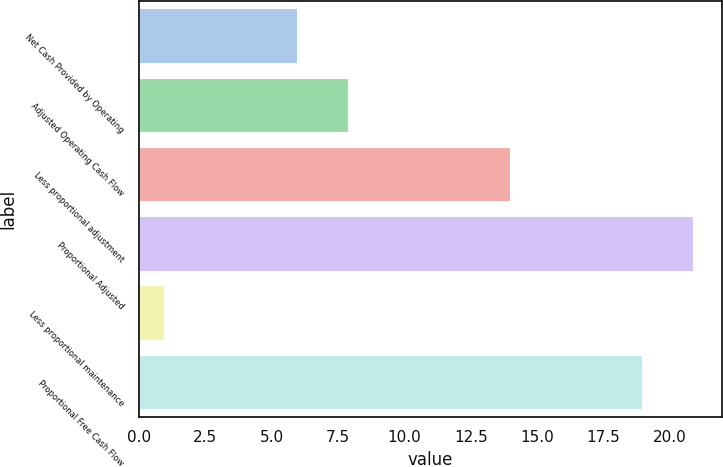Convert chart. <chart><loc_0><loc_0><loc_500><loc_500><bar_chart><fcel>Net Cash Provided by Operating<fcel>Adjusted Operating Cash Flow<fcel>Less proportional adjustment<fcel>Proportional Adjusted<fcel>Less proportional maintenance<fcel>Proportional Free Cash Flow<nl><fcel>6<fcel>7.9<fcel>14<fcel>20.9<fcel>1<fcel>19<nl></chart> 